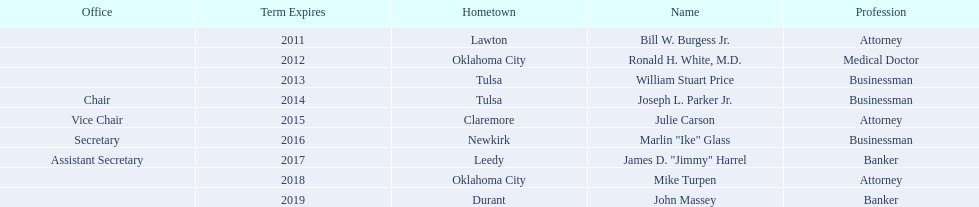How many of the current state regents will be in office until at least 2016? 4. 